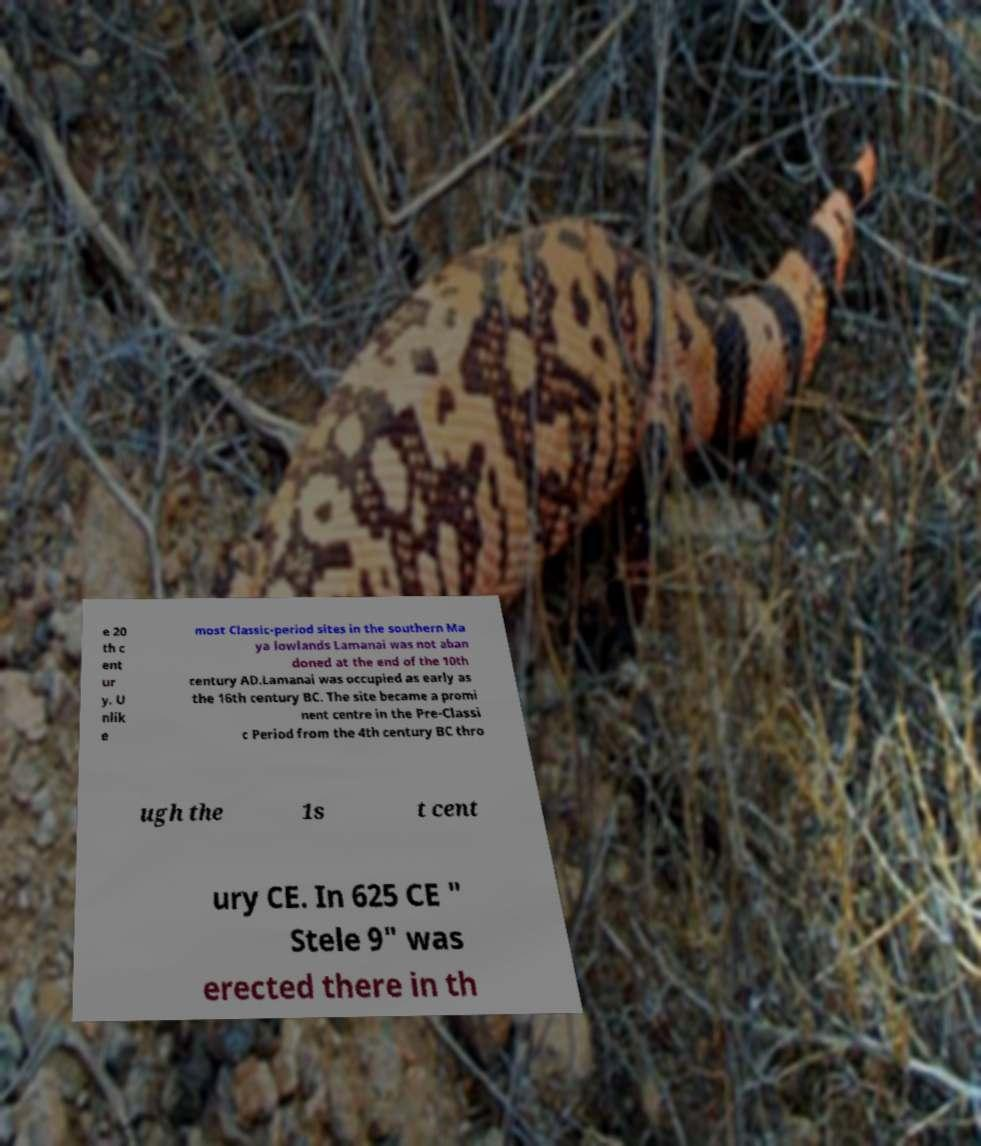Please identify and transcribe the text found in this image. e 20 th c ent ur y. U nlik e most Classic-period sites in the southern Ma ya lowlands Lamanai was not aban doned at the end of the 10th century AD.Lamanai was occupied as early as the 16th century BC. The site became a promi nent centre in the Pre-Classi c Period from the 4th century BC thro ugh the 1s t cent ury CE. In 625 CE " Stele 9" was erected there in th 